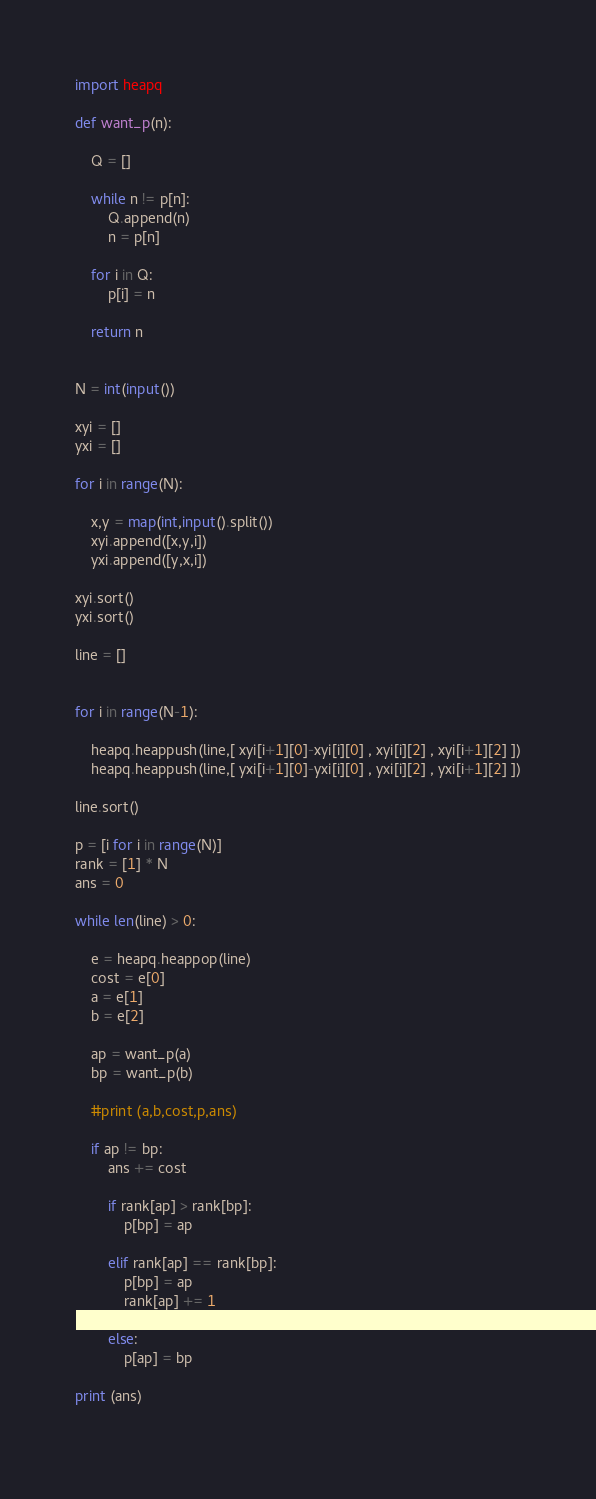<code> <loc_0><loc_0><loc_500><loc_500><_Python_>import heapq

def want_p(n):

    Q = []

    while n != p[n]:
        Q.append(n)
        n = p[n]

    for i in Q:
        p[i] = n

    return n


N = int(input())

xyi = []
yxi = []

for i in range(N):

    x,y = map(int,input().split())
    xyi.append([x,y,i])
    yxi.append([y,x,i])

xyi.sort()
yxi.sort()

line = []


for i in range(N-1):

    heapq.heappush(line,[ xyi[i+1][0]-xyi[i][0] , xyi[i][2] , xyi[i+1][2] ])
    heapq.heappush(line,[ yxi[i+1][0]-yxi[i][0] , yxi[i][2] , yxi[i+1][2] ])

line.sort()

p = [i for i in range(N)]
rank = [1] * N
ans = 0

while len(line) > 0:

    e = heapq.heappop(line)
    cost = e[0]
    a = e[1]
    b = e[2]

    ap = want_p(a)
    bp = want_p(b)

    #print (a,b,cost,p,ans)

    if ap != bp:
        ans += cost

        if rank[ap] > rank[bp]:
            p[bp] = ap

        elif rank[ap] == rank[bp]:
            p[bp] = ap
            rank[ap] += 1

        else:
            p[ap] = bp

print (ans)
        </code> 